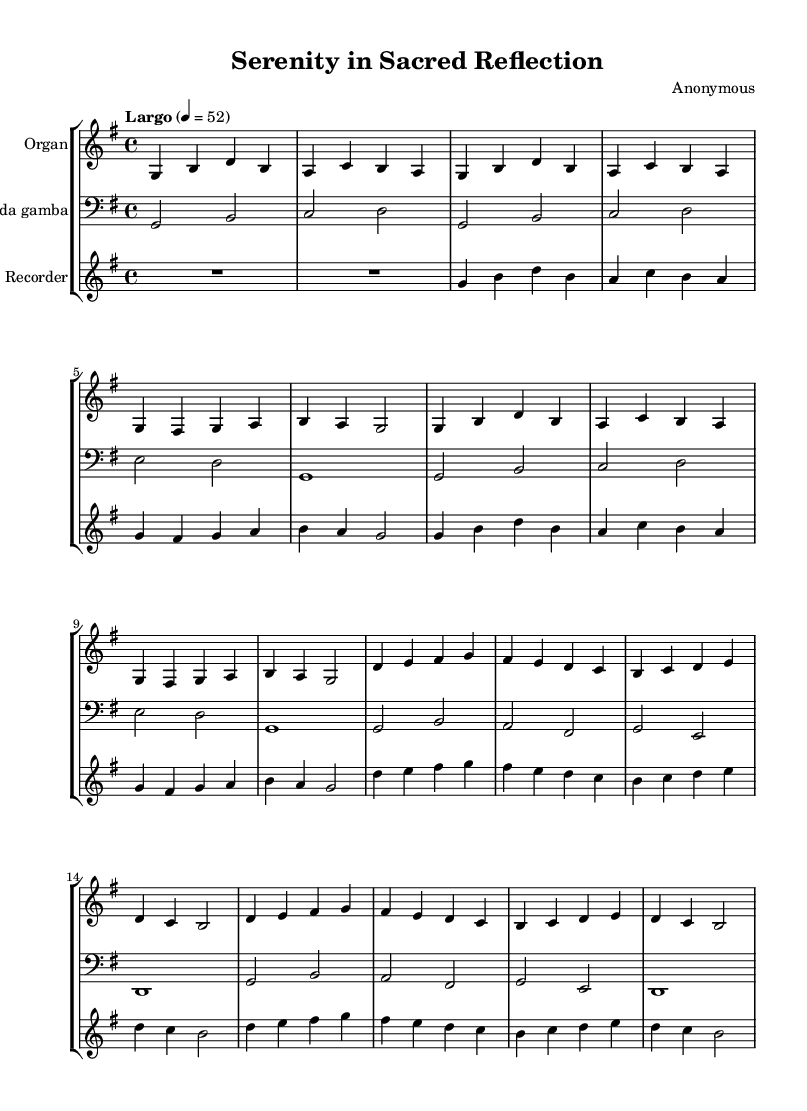What is the key signature of this music? The key signature is G major, which has one sharp (F#). This can be determined by looking at the key signature section after the clef symbol at the beginning of the staff, which indicates G major.
Answer: G major What is the time signature of this piece? The time signature is 4/4, as indicated at the beginning of the score next to the clef. This means there are four beats in each measure and a quarter note gets one beat.
Answer: 4/4 What is the tempo marking given for this music? The tempo marking is "Largo," which indicates a slow tempo. This is stated at the beginning of the score with the specific note value (4 = 52) that provides a slightly more specific reference for the timing.
Answer: Largo How many measures are in Theme A? Theme A consists of four measures as seen in the repeated sections marked within the music, each of which contains a definitive phrase before transitioning to the next theme.
Answer: 4 What instruments are included in this piece? The instruments included in this piece are the organ, viola da gamba, and recorder. This can be found at the top of each staff, where the instrument names are specified.
Answer: Organ, viola da gamba, recorder In which part of the score do you see the Introduction? The Introduction is the first two measures of the music, indicated at the very start before Theme A. The notes are distinct and laid out before any themes are introduced.
Answer: First two measures How is the music data structured in terms of thematic material? The music is structured in two distinct themes (Theme A and Theme B) with several repetitions of Theme A, showcasing the Baroque style. The transitions from one theme to another indicate the thematic organization within the score.
Answer: Two themes 